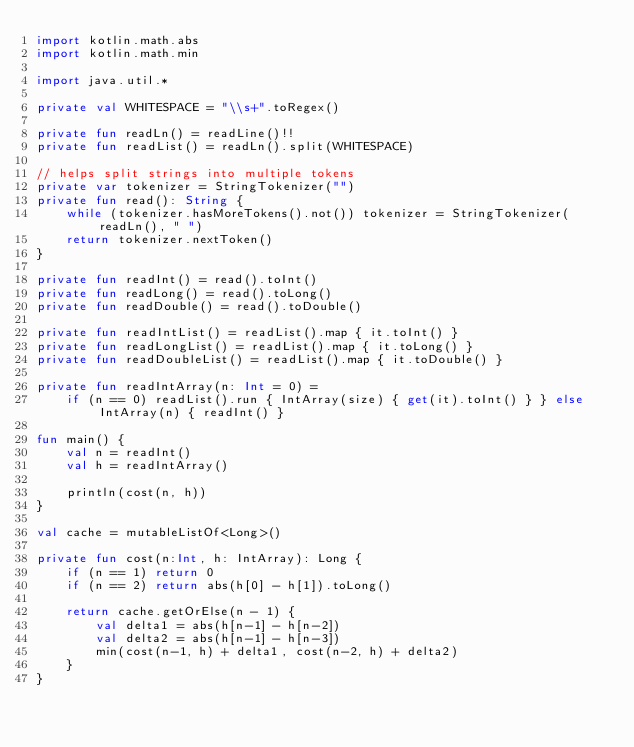Convert code to text. <code><loc_0><loc_0><loc_500><loc_500><_Kotlin_>import kotlin.math.abs
import kotlin.math.min

import java.util.*

private val WHITESPACE = "\\s+".toRegex()

private fun readLn() = readLine()!!
private fun readList() = readLn().split(WHITESPACE)

// helps split strings into multiple tokens
private var tokenizer = StringTokenizer("")
private fun read(): String {
    while (tokenizer.hasMoreTokens().not()) tokenizer = StringTokenizer(readLn(), " ")
    return tokenizer.nextToken()
}

private fun readInt() = read().toInt()
private fun readLong() = read().toLong()
private fun readDouble() = read().toDouble()

private fun readIntList() = readList().map { it.toInt() }
private fun readLongList() = readList().map { it.toLong() }
private fun readDoubleList() = readList().map { it.toDouble() }

private fun readIntArray(n: Int = 0) =
    if (n == 0) readList().run { IntArray(size) { get(it).toInt() } } else IntArray(n) { readInt() }

fun main() {
    val n = readInt()
    val h = readIntArray()

    println(cost(n, h))
}

val cache = mutableListOf<Long>()

private fun cost(n:Int, h: IntArray): Long {
    if (n == 1) return 0
    if (n == 2) return abs(h[0] - h[1]).toLong()

    return cache.getOrElse(n - 1) {
        val delta1 = abs(h[n-1] - h[n-2])
        val delta2 = abs(h[n-1] - h[n-3])
        min(cost(n-1, h) + delta1, cost(n-2, h) + delta2)
    }
}</code> 